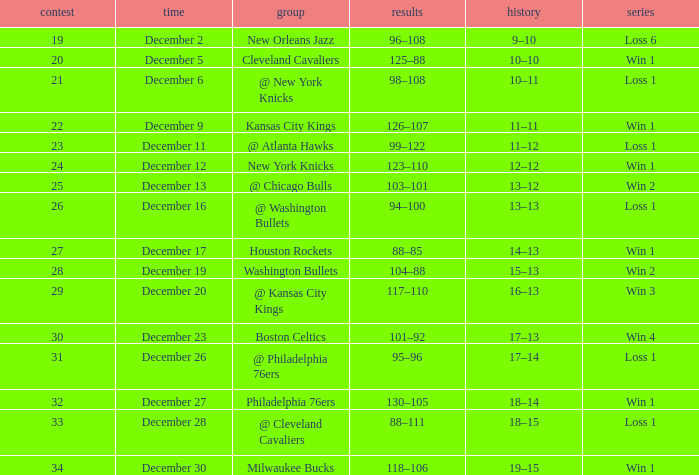What contest concluded with a score of 101–92? 30.0. 